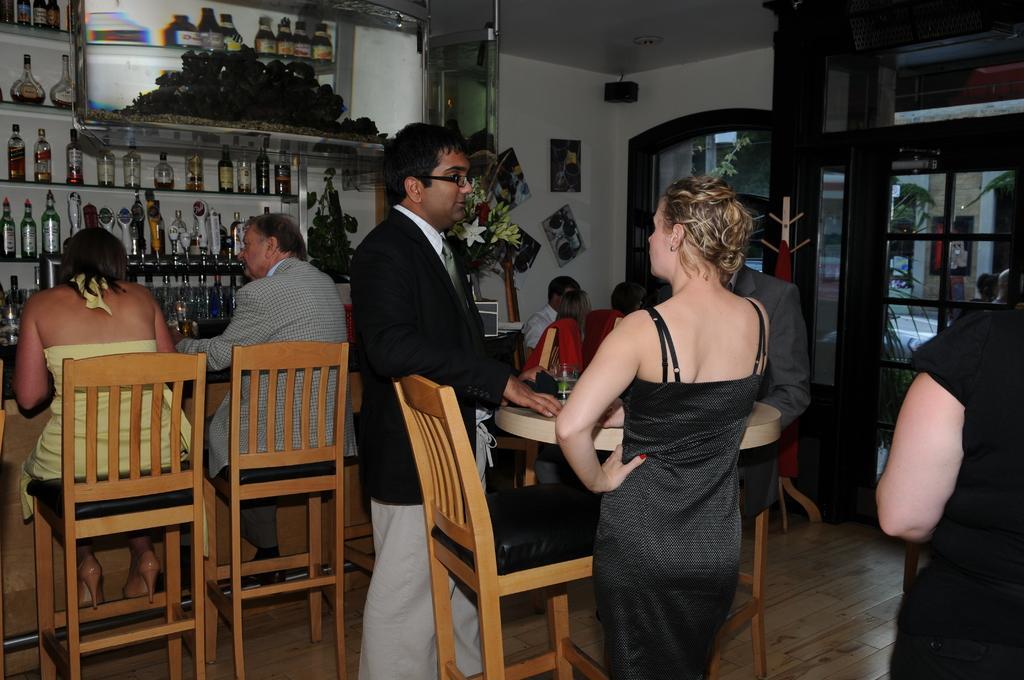Could you give a brief overview of what you see in this image? There are two persons standing in front of a table and there are group of members sitting beside them and there are wine bottles in the left corner. 